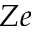Convert formula to latex. <formula><loc_0><loc_0><loc_500><loc_500>Z e</formula> 